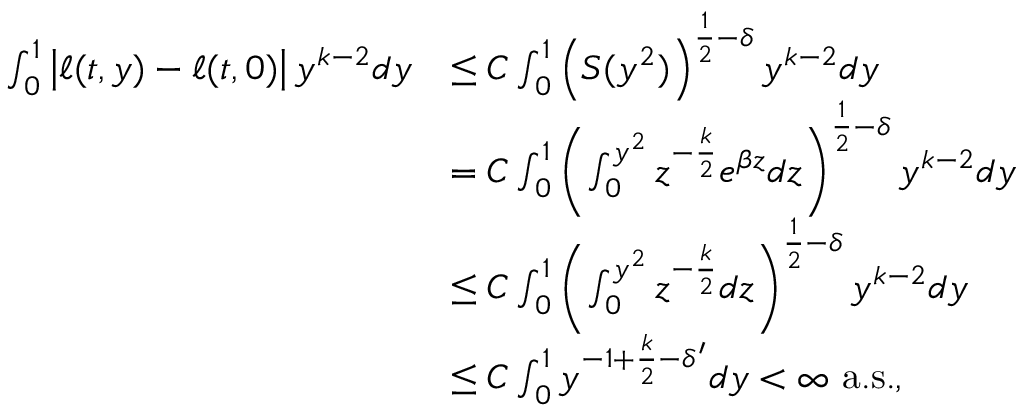<formula> <loc_0><loc_0><loc_500><loc_500>\begin{array} { r l } { \int _ { 0 } ^ { 1 } \left | \ell ( t , y ) - \ell ( t , 0 ) \right | y ^ { k - 2 } d y } & { \leq C \int _ { 0 } ^ { 1 } \left ( S ( y ^ { 2 } ) \right ) ^ { \frac { 1 } { 2 } - \delta } y ^ { k - 2 } d y } \\ & { = C \int _ { 0 } ^ { 1 } \left ( \int _ { 0 } ^ { y ^ { 2 } } z ^ { - \frac { k } { 2 } } e ^ { \beta z } d z \right ) ^ { \frac { 1 } { 2 } - \delta } y ^ { k - 2 } d y } \\ & { \leq C \int _ { 0 } ^ { 1 } \left ( \int _ { 0 } ^ { y ^ { 2 } } z ^ { - \frac { k } { 2 } } d z \right ) ^ { \frac { 1 } { 2 } - \delta } y ^ { k - 2 } d y } \\ & { \leq C \int _ { 0 } ^ { 1 } y ^ { - 1 + \frac { k } { 2 } - \delta ^ { \prime } } d y < \infty \ a . s . , } \end{array}</formula> 